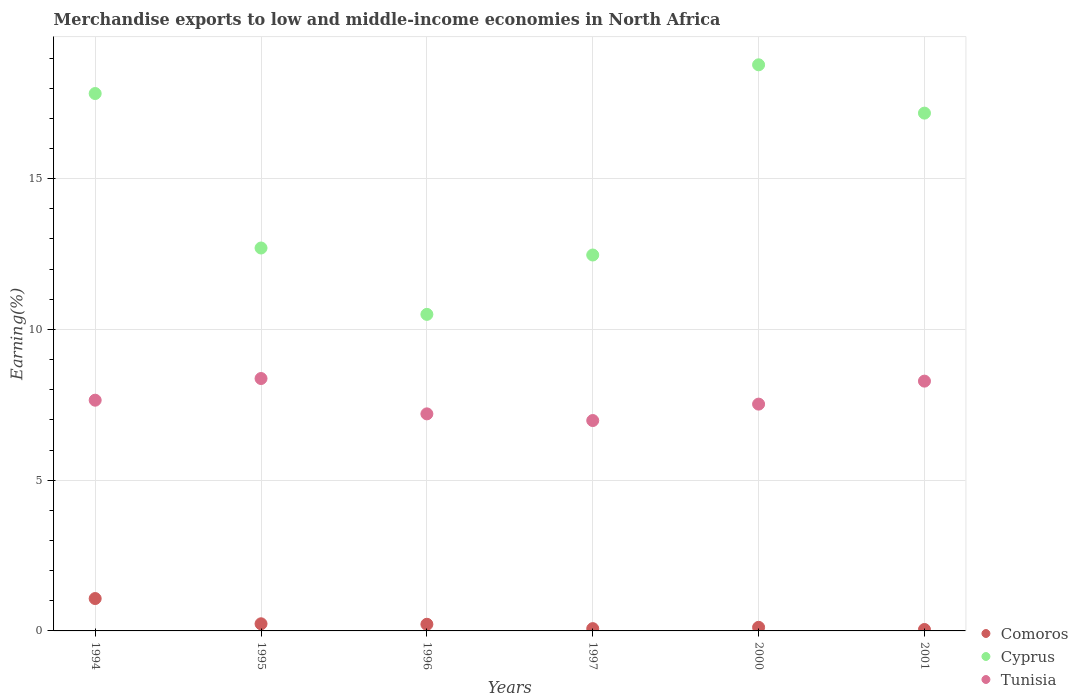What is the percentage of amount earned from merchandise exports in Comoros in 2001?
Provide a short and direct response. 0.05. Across all years, what is the maximum percentage of amount earned from merchandise exports in Tunisia?
Provide a short and direct response. 8.37. Across all years, what is the minimum percentage of amount earned from merchandise exports in Cyprus?
Offer a very short reply. 10.5. What is the total percentage of amount earned from merchandise exports in Tunisia in the graph?
Provide a succinct answer. 46.01. What is the difference between the percentage of amount earned from merchandise exports in Comoros in 1997 and that in 2000?
Provide a succinct answer. -0.04. What is the difference between the percentage of amount earned from merchandise exports in Cyprus in 1995 and the percentage of amount earned from merchandise exports in Tunisia in 1997?
Keep it short and to the point. 5.72. What is the average percentage of amount earned from merchandise exports in Tunisia per year?
Offer a terse response. 7.67. In the year 1997, what is the difference between the percentage of amount earned from merchandise exports in Cyprus and percentage of amount earned from merchandise exports in Comoros?
Ensure brevity in your answer.  12.39. In how many years, is the percentage of amount earned from merchandise exports in Cyprus greater than 10 %?
Your response must be concise. 6. What is the ratio of the percentage of amount earned from merchandise exports in Tunisia in 1995 to that in 1996?
Your response must be concise. 1.16. Is the difference between the percentage of amount earned from merchandise exports in Cyprus in 1994 and 1995 greater than the difference between the percentage of amount earned from merchandise exports in Comoros in 1994 and 1995?
Offer a very short reply. Yes. What is the difference between the highest and the second highest percentage of amount earned from merchandise exports in Cyprus?
Offer a terse response. 0.95. What is the difference between the highest and the lowest percentage of amount earned from merchandise exports in Cyprus?
Keep it short and to the point. 8.28. In how many years, is the percentage of amount earned from merchandise exports in Comoros greater than the average percentage of amount earned from merchandise exports in Comoros taken over all years?
Give a very brief answer. 1. Is the sum of the percentage of amount earned from merchandise exports in Comoros in 1996 and 2001 greater than the maximum percentage of amount earned from merchandise exports in Cyprus across all years?
Your answer should be very brief. No. Is it the case that in every year, the sum of the percentage of amount earned from merchandise exports in Cyprus and percentage of amount earned from merchandise exports in Comoros  is greater than the percentage of amount earned from merchandise exports in Tunisia?
Your answer should be very brief. Yes. Is the percentage of amount earned from merchandise exports in Tunisia strictly greater than the percentage of amount earned from merchandise exports in Cyprus over the years?
Give a very brief answer. No. How many dotlines are there?
Provide a succinct answer. 3. What is the difference between two consecutive major ticks on the Y-axis?
Offer a very short reply. 5. Does the graph contain any zero values?
Provide a short and direct response. No. Does the graph contain grids?
Ensure brevity in your answer.  Yes. Where does the legend appear in the graph?
Your answer should be very brief. Bottom right. How many legend labels are there?
Provide a succinct answer. 3. How are the legend labels stacked?
Keep it short and to the point. Vertical. What is the title of the graph?
Give a very brief answer. Merchandise exports to low and middle-income economies in North Africa. Does "Azerbaijan" appear as one of the legend labels in the graph?
Your answer should be compact. No. What is the label or title of the Y-axis?
Make the answer very short. Earning(%). What is the Earning(%) in Comoros in 1994?
Your answer should be very brief. 1.07. What is the Earning(%) in Cyprus in 1994?
Offer a very short reply. 17.82. What is the Earning(%) in Tunisia in 1994?
Keep it short and to the point. 7.65. What is the Earning(%) in Comoros in 1995?
Provide a short and direct response. 0.24. What is the Earning(%) in Cyprus in 1995?
Keep it short and to the point. 12.7. What is the Earning(%) in Tunisia in 1995?
Your response must be concise. 8.37. What is the Earning(%) in Comoros in 1996?
Your response must be concise. 0.22. What is the Earning(%) of Cyprus in 1996?
Provide a succinct answer. 10.5. What is the Earning(%) of Tunisia in 1996?
Your response must be concise. 7.2. What is the Earning(%) of Comoros in 1997?
Keep it short and to the point. 0.08. What is the Earning(%) in Cyprus in 1997?
Offer a very short reply. 12.47. What is the Earning(%) in Tunisia in 1997?
Keep it short and to the point. 6.98. What is the Earning(%) in Comoros in 2000?
Your answer should be very brief. 0.12. What is the Earning(%) of Cyprus in 2000?
Ensure brevity in your answer.  18.78. What is the Earning(%) of Tunisia in 2000?
Your answer should be very brief. 7.52. What is the Earning(%) in Comoros in 2001?
Keep it short and to the point. 0.05. What is the Earning(%) in Cyprus in 2001?
Your answer should be very brief. 17.17. What is the Earning(%) in Tunisia in 2001?
Keep it short and to the point. 8.28. Across all years, what is the maximum Earning(%) of Comoros?
Provide a succinct answer. 1.07. Across all years, what is the maximum Earning(%) in Cyprus?
Give a very brief answer. 18.78. Across all years, what is the maximum Earning(%) of Tunisia?
Offer a terse response. 8.37. Across all years, what is the minimum Earning(%) in Comoros?
Your response must be concise. 0.05. Across all years, what is the minimum Earning(%) of Cyprus?
Ensure brevity in your answer.  10.5. Across all years, what is the minimum Earning(%) in Tunisia?
Keep it short and to the point. 6.98. What is the total Earning(%) of Comoros in the graph?
Provide a short and direct response. 1.77. What is the total Earning(%) of Cyprus in the graph?
Offer a terse response. 89.44. What is the total Earning(%) of Tunisia in the graph?
Provide a succinct answer. 46.01. What is the difference between the Earning(%) in Comoros in 1994 and that in 1995?
Ensure brevity in your answer.  0.84. What is the difference between the Earning(%) of Cyprus in 1994 and that in 1995?
Provide a succinct answer. 5.12. What is the difference between the Earning(%) of Tunisia in 1994 and that in 1995?
Give a very brief answer. -0.72. What is the difference between the Earning(%) in Comoros in 1994 and that in 1996?
Provide a short and direct response. 0.85. What is the difference between the Earning(%) in Cyprus in 1994 and that in 1996?
Provide a short and direct response. 7.32. What is the difference between the Earning(%) in Tunisia in 1994 and that in 1996?
Ensure brevity in your answer.  0.45. What is the difference between the Earning(%) of Comoros in 1994 and that in 1997?
Offer a terse response. 1. What is the difference between the Earning(%) of Cyprus in 1994 and that in 1997?
Make the answer very short. 5.36. What is the difference between the Earning(%) of Tunisia in 1994 and that in 1997?
Offer a very short reply. 0.67. What is the difference between the Earning(%) in Comoros in 1994 and that in 2000?
Provide a succinct answer. 0.95. What is the difference between the Earning(%) in Cyprus in 1994 and that in 2000?
Provide a short and direct response. -0.95. What is the difference between the Earning(%) in Tunisia in 1994 and that in 2000?
Your answer should be compact. 0.13. What is the difference between the Earning(%) in Comoros in 1994 and that in 2001?
Your response must be concise. 1.03. What is the difference between the Earning(%) of Cyprus in 1994 and that in 2001?
Your answer should be very brief. 0.65. What is the difference between the Earning(%) in Tunisia in 1994 and that in 2001?
Your response must be concise. -0.63. What is the difference between the Earning(%) in Comoros in 1995 and that in 1996?
Offer a terse response. 0.02. What is the difference between the Earning(%) in Cyprus in 1995 and that in 1996?
Make the answer very short. 2.2. What is the difference between the Earning(%) in Tunisia in 1995 and that in 1996?
Your response must be concise. 1.17. What is the difference between the Earning(%) in Comoros in 1995 and that in 1997?
Ensure brevity in your answer.  0.16. What is the difference between the Earning(%) of Cyprus in 1995 and that in 1997?
Your answer should be compact. 0.23. What is the difference between the Earning(%) of Tunisia in 1995 and that in 1997?
Give a very brief answer. 1.39. What is the difference between the Earning(%) of Comoros in 1995 and that in 2000?
Your response must be concise. 0.12. What is the difference between the Earning(%) in Cyprus in 1995 and that in 2000?
Keep it short and to the point. -6.08. What is the difference between the Earning(%) of Tunisia in 1995 and that in 2000?
Offer a terse response. 0.85. What is the difference between the Earning(%) in Comoros in 1995 and that in 2001?
Your answer should be compact. 0.19. What is the difference between the Earning(%) in Cyprus in 1995 and that in 2001?
Offer a very short reply. -4.47. What is the difference between the Earning(%) of Tunisia in 1995 and that in 2001?
Provide a succinct answer. 0.09. What is the difference between the Earning(%) in Comoros in 1996 and that in 1997?
Your response must be concise. 0.14. What is the difference between the Earning(%) in Cyprus in 1996 and that in 1997?
Your answer should be compact. -1.97. What is the difference between the Earning(%) in Tunisia in 1996 and that in 1997?
Your answer should be compact. 0.22. What is the difference between the Earning(%) of Comoros in 1996 and that in 2000?
Ensure brevity in your answer.  0.1. What is the difference between the Earning(%) in Cyprus in 1996 and that in 2000?
Keep it short and to the point. -8.28. What is the difference between the Earning(%) of Tunisia in 1996 and that in 2000?
Keep it short and to the point. -0.32. What is the difference between the Earning(%) in Comoros in 1996 and that in 2001?
Give a very brief answer. 0.17. What is the difference between the Earning(%) in Cyprus in 1996 and that in 2001?
Offer a very short reply. -6.67. What is the difference between the Earning(%) of Tunisia in 1996 and that in 2001?
Provide a short and direct response. -1.09. What is the difference between the Earning(%) in Comoros in 1997 and that in 2000?
Offer a terse response. -0.04. What is the difference between the Earning(%) of Cyprus in 1997 and that in 2000?
Your answer should be very brief. -6.31. What is the difference between the Earning(%) in Tunisia in 1997 and that in 2000?
Your answer should be compact. -0.54. What is the difference between the Earning(%) in Comoros in 1997 and that in 2001?
Keep it short and to the point. 0.03. What is the difference between the Earning(%) in Cyprus in 1997 and that in 2001?
Give a very brief answer. -4.71. What is the difference between the Earning(%) of Tunisia in 1997 and that in 2001?
Provide a short and direct response. -1.31. What is the difference between the Earning(%) of Comoros in 2000 and that in 2001?
Make the answer very short. 0.07. What is the difference between the Earning(%) in Cyprus in 2000 and that in 2001?
Offer a very short reply. 1.6. What is the difference between the Earning(%) of Tunisia in 2000 and that in 2001?
Your answer should be very brief. -0.76. What is the difference between the Earning(%) in Comoros in 1994 and the Earning(%) in Cyprus in 1995?
Keep it short and to the point. -11.63. What is the difference between the Earning(%) in Comoros in 1994 and the Earning(%) in Tunisia in 1995?
Offer a terse response. -7.3. What is the difference between the Earning(%) of Cyprus in 1994 and the Earning(%) of Tunisia in 1995?
Your answer should be compact. 9.45. What is the difference between the Earning(%) in Comoros in 1994 and the Earning(%) in Cyprus in 1996?
Make the answer very short. -9.42. What is the difference between the Earning(%) of Comoros in 1994 and the Earning(%) of Tunisia in 1996?
Provide a succinct answer. -6.12. What is the difference between the Earning(%) of Cyprus in 1994 and the Earning(%) of Tunisia in 1996?
Keep it short and to the point. 10.62. What is the difference between the Earning(%) in Comoros in 1994 and the Earning(%) in Cyprus in 1997?
Provide a short and direct response. -11.39. What is the difference between the Earning(%) in Comoros in 1994 and the Earning(%) in Tunisia in 1997?
Make the answer very short. -5.9. What is the difference between the Earning(%) of Cyprus in 1994 and the Earning(%) of Tunisia in 1997?
Make the answer very short. 10.85. What is the difference between the Earning(%) in Comoros in 1994 and the Earning(%) in Cyprus in 2000?
Provide a short and direct response. -17.7. What is the difference between the Earning(%) in Comoros in 1994 and the Earning(%) in Tunisia in 2000?
Offer a terse response. -6.45. What is the difference between the Earning(%) in Cyprus in 1994 and the Earning(%) in Tunisia in 2000?
Your answer should be compact. 10.3. What is the difference between the Earning(%) of Comoros in 1994 and the Earning(%) of Cyprus in 2001?
Your answer should be compact. -16.1. What is the difference between the Earning(%) of Comoros in 1994 and the Earning(%) of Tunisia in 2001?
Make the answer very short. -7.21. What is the difference between the Earning(%) of Cyprus in 1994 and the Earning(%) of Tunisia in 2001?
Your answer should be compact. 9.54. What is the difference between the Earning(%) in Comoros in 1995 and the Earning(%) in Cyprus in 1996?
Provide a short and direct response. -10.26. What is the difference between the Earning(%) in Comoros in 1995 and the Earning(%) in Tunisia in 1996?
Your response must be concise. -6.96. What is the difference between the Earning(%) in Cyprus in 1995 and the Earning(%) in Tunisia in 1996?
Offer a very short reply. 5.5. What is the difference between the Earning(%) of Comoros in 1995 and the Earning(%) of Cyprus in 1997?
Make the answer very short. -12.23. What is the difference between the Earning(%) of Comoros in 1995 and the Earning(%) of Tunisia in 1997?
Give a very brief answer. -6.74. What is the difference between the Earning(%) in Cyprus in 1995 and the Earning(%) in Tunisia in 1997?
Make the answer very short. 5.72. What is the difference between the Earning(%) of Comoros in 1995 and the Earning(%) of Cyprus in 2000?
Provide a short and direct response. -18.54. What is the difference between the Earning(%) of Comoros in 1995 and the Earning(%) of Tunisia in 2000?
Your response must be concise. -7.29. What is the difference between the Earning(%) in Cyprus in 1995 and the Earning(%) in Tunisia in 2000?
Provide a succinct answer. 5.18. What is the difference between the Earning(%) in Comoros in 1995 and the Earning(%) in Cyprus in 2001?
Keep it short and to the point. -16.94. What is the difference between the Earning(%) in Comoros in 1995 and the Earning(%) in Tunisia in 2001?
Provide a succinct answer. -8.05. What is the difference between the Earning(%) of Cyprus in 1995 and the Earning(%) of Tunisia in 2001?
Make the answer very short. 4.42. What is the difference between the Earning(%) in Comoros in 1996 and the Earning(%) in Cyprus in 1997?
Your answer should be very brief. -12.25. What is the difference between the Earning(%) in Comoros in 1996 and the Earning(%) in Tunisia in 1997?
Offer a very short reply. -6.76. What is the difference between the Earning(%) in Cyprus in 1996 and the Earning(%) in Tunisia in 1997?
Offer a very short reply. 3.52. What is the difference between the Earning(%) of Comoros in 1996 and the Earning(%) of Cyprus in 2000?
Make the answer very short. -18.56. What is the difference between the Earning(%) of Comoros in 1996 and the Earning(%) of Tunisia in 2000?
Offer a very short reply. -7.3. What is the difference between the Earning(%) in Cyprus in 1996 and the Earning(%) in Tunisia in 2000?
Give a very brief answer. 2.98. What is the difference between the Earning(%) in Comoros in 1996 and the Earning(%) in Cyprus in 2001?
Give a very brief answer. -16.95. What is the difference between the Earning(%) of Comoros in 1996 and the Earning(%) of Tunisia in 2001?
Give a very brief answer. -8.06. What is the difference between the Earning(%) in Cyprus in 1996 and the Earning(%) in Tunisia in 2001?
Keep it short and to the point. 2.21. What is the difference between the Earning(%) in Comoros in 1997 and the Earning(%) in Cyprus in 2000?
Offer a very short reply. -18.7. What is the difference between the Earning(%) in Comoros in 1997 and the Earning(%) in Tunisia in 2000?
Give a very brief answer. -7.45. What is the difference between the Earning(%) of Cyprus in 1997 and the Earning(%) of Tunisia in 2000?
Your response must be concise. 4.95. What is the difference between the Earning(%) in Comoros in 1997 and the Earning(%) in Cyprus in 2001?
Offer a very short reply. -17.1. What is the difference between the Earning(%) in Comoros in 1997 and the Earning(%) in Tunisia in 2001?
Your response must be concise. -8.21. What is the difference between the Earning(%) of Cyprus in 1997 and the Earning(%) of Tunisia in 2001?
Keep it short and to the point. 4.18. What is the difference between the Earning(%) in Comoros in 2000 and the Earning(%) in Cyprus in 2001?
Your response must be concise. -17.05. What is the difference between the Earning(%) of Comoros in 2000 and the Earning(%) of Tunisia in 2001?
Your response must be concise. -8.17. What is the difference between the Earning(%) in Cyprus in 2000 and the Earning(%) in Tunisia in 2001?
Your answer should be compact. 10.49. What is the average Earning(%) of Comoros per year?
Offer a terse response. 0.3. What is the average Earning(%) of Cyprus per year?
Give a very brief answer. 14.91. What is the average Earning(%) of Tunisia per year?
Provide a succinct answer. 7.67. In the year 1994, what is the difference between the Earning(%) of Comoros and Earning(%) of Cyprus?
Your answer should be very brief. -16.75. In the year 1994, what is the difference between the Earning(%) of Comoros and Earning(%) of Tunisia?
Ensure brevity in your answer.  -6.58. In the year 1994, what is the difference between the Earning(%) in Cyprus and Earning(%) in Tunisia?
Keep it short and to the point. 10.17. In the year 1995, what is the difference between the Earning(%) of Comoros and Earning(%) of Cyprus?
Provide a short and direct response. -12.46. In the year 1995, what is the difference between the Earning(%) in Comoros and Earning(%) in Tunisia?
Provide a succinct answer. -8.13. In the year 1995, what is the difference between the Earning(%) of Cyprus and Earning(%) of Tunisia?
Provide a succinct answer. 4.33. In the year 1996, what is the difference between the Earning(%) of Comoros and Earning(%) of Cyprus?
Your answer should be very brief. -10.28. In the year 1996, what is the difference between the Earning(%) of Comoros and Earning(%) of Tunisia?
Keep it short and to the point. -6.98. In the year 1996, what is the difference between the Earning(%) of Cyprus and Earning(%) of Tunisia?
Your response must be concise. 3.3. In the year 1997, what is the difference between the Earning(%) in Comoros and Earning(%) in Cyprus?
Ensure brevity in your answer.  -12.39. In the year 1997, what is the difference between the Earning(%) of Comoros and Earning(%) of Tunisia?
Give a very brief answer. -6.9. In the year 1997, what is the difference between the Earning(%) of Cyprus and Earning(%) of Tunisia?
Ensure brevity in your answer.  5.49. In the year 2000, what is the difference between the Earning(%) of Comoros and Earning(%) of Cyprus?
Offer a terse response. -18.66. In the year 2000, what is the difference between the Earning(%) of Comoros and Earning(%) of Tunisia?
Provide a short and direct response. -7.4. In the year 2000, what is the difference between the Earning(%) of Cyprus and Earning(%) of Tunisia?
Ensure brevity in your answer.  11.25. In the year 2001, what is the difference between the Earning(%) of Comoros and Earning(%) of Cyprus?
Your answer should be very brief. -17.13. In the year 2001, what is the difference between the Earning(%) in Comoros and Earning(%) in Tunisia?
Keep it short and to the point. -8.24. In the year 2001, what is the difference between the Earning(%) of Cyprus and Earning(%) of Tunisia?
Your answer should be very brief. 8.89. What is the ratio of the Earning(%) of Comoros in 1994 to that in 1995?
Keep it short and to the point. 4.54. What is the ratio of the Earning(%) in Cyprus in 1994 to that in 1995?
Give a very brief answer. 1.4. What is the ratio of the Earning(%) in Tunisia in 1994 to that in 1995?
Ensure brevity in your answer.  0.91. What is the ratio of the Earning(%) in Comoros in 1994 to that in 1996?
Offer a terse response. 4.87. What is the ratio of the Earning(%) in Cyprus in 1994 to that in 1996?
Offer a terse response. 1.7. What is the ratio of the Earning(%) of Tunisia in 1994 to that in 1996?
Give a very brief answer. 1.06. What is the ratio of the Earning(%) in Comoros in 1994 to that in 1997?
Offer a terse response. 14.13. What is the ratio of the Earning(%) of Cyprus in 1994 to that in 1997?
Ensure brevity in your answer.  1.43. What is the ratio of the Earning(%) in Tunisia in 1994 to that in 1997?
Give a very brief answer. 1.1. What is the ratio of the Earning(%) of Comoros in 1994 to that in 2000?
Offer a terse response. 9.03. What is the ratio of the Earning(%) of Cyprus in 1994 to that in 2000?
Make the answer very short. 0.95. What is the ratio of the Earning(%) of Tunisia in 1994 to that in 2000?
Give a very brief answer. 1.02. What is the ratio of the Earning(%) of Comoros in 1994 to that in 2001?
Make the answer very short. 22.7. What is the ratio of the Earning(%) in Cyprus in 1994 to that in 2001?
Offer a terse response. 1.04. What is the ratio of the Earning(%) of Tunisia in 1994 to that in 2001?
Provide a succinct answer. 0.92. What is the ratio of the Earning(%) of Comoros in 1995 to that in 1996?
Offer a very short reply. 1.07. What is the ratio of the Earning(%) in Cyprus in 1995 to that in 1996?
Keep it short and to the point. 1.21. What is the ratio of the Earning(%) of Tunisia in 1995 to that in 1996?
Your answer should be very brief. 1.16. What is the ratio of the Earning(%) in Comoros in 1995 to that in 1997?
Provide a short and direct response. 3.11. What is the ratio of the Earning(%) in Cyprus in 1995 to that in 1997?
Keep it short and to the point. 1.02. What is the ratio of the Earning(%) of Tunisia in 1995 to that in 1997?
Offer a terse response. 1.2. What is the ratio of the Earning(%) in Comoros in 1995 to that in 2000?
Offer a very short reply. 1.99. What is the ratio of the Earning(%) of Cyprus in 1995 to that in 2000?
Your answer should be very brief. 0.68. What is the ratio of the Earning(%) of Tunisia in 1995 to that in 2000?
Offer a very short reply. 1.11. What is the ratio of the Earning(%) in Comoros in 1995 to that in 2001?
Offer a terse response. 5. What is the ratio of the Earning(%) of Cyprus in 1995 to that in 2001?
Your answer should be compact. 0.74. What is the ratio of the Earning(%) of Tunisia in 1995 to that in 2001?
Offer a terse response. 1.01. What is the ratio of the Earning(%) in Comoros in 1996 to that in 1997?
Your answer should be compact. 2.9. What is the ratio of the Earning(%) of Cyprus in 1996 to that in 1997?
Offer a terse response. 0.84. What is the ratio of the Earning(%) of Tunisia in 1996 to that in 1997?
Ensure brevity in your answer.  1.03. What is the ratio of the Earning(%) in Comoros in 1996 to that in 2000?
Give a very brief answer. 1.85. What is the ratio of the Earning(%) of Cyprus in 1996 to that in 2000?
Ensure brevity in your answer.  0.56. What is the ratio of the Earning(%) in Tunisia in 1996 to that in 2000?
Your answer should be very brief. 0.96. What is the ratio of the Earning(%) of Comoros in 1996 to that in 2001?
Provide a succinct answer. 4.66. What is the ratio of the Earning(%) in Cyprus in 1996 to that in 2001?
Your response must be concise. 0.61. What is the ratio of the Earning(%) in Tunisia in 1996 to that in 2001?
Provide a short and direct response. 0.87. What is the ratio of the Earning(%) in Comoros in 1997 to that in 2000?
Your response must be concise. 0.64. What is the ratio of the Earning(%) in Cyprus in 1997 to that in 2000?
Offer a very short reply. 0.66. What is the ratio of the Earning(%) of Tunisia in 1997 to that in 2000?
Offer a very short reply. 0.93. What is the ratio of the Earning(%) in Comoros in 1997 to that in 2001?
Ensure brevity in your answer.  1.61. What is the ratio of the Earning(%) of Cyprus in 1997 to that in 2001?
Provide a short and direct response. 0.73. What is the ratio of the Earning(%) in Tunisia in 1997 to that in 2001?
Provide a short and direct response. 0.84. What is the ratio of the Earning(%) of Comoros in 2000 to that in 2001?
Provide a short and direct response. 2.52. What is the ratio of the Earning(%) in Cyprus in 2000 to that in 2001?
Provide a succinct answer. 1.09. What is the ratio of the Earning(%) in Tunisia in 2000 to that in 2001?
Offer a very short reply. 0.91. What is the difference between the highest and the second highest Earning(%) in Comoros?
Offer a very short reply. 0.84. What is the difference between the highest and the second highest Earning(%) in Tunisia?
Give a very brief answer. 0.09. What is the difference between the highest and the lowest Earning(%) in Comoros?
Your answer should be compact. 1.03. What is the difference between the highest and the lowest Earning(%) in Cyprus?
Provide a short and direct response. 8.28. What is the difference between the highest and the lowest Earning(%) of Tunisia?
Make the answer very short. 1.39. 